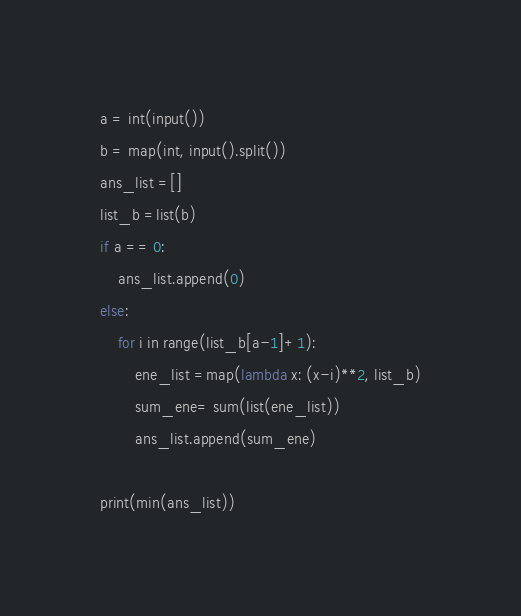Convert code to text. <code><loc_0><loc_0><loc_500><loc_500><_Python_>a = int(input())
b = map(int, input().split())
ans_list =[]
list_b =list(b)
if a == 0:
    ans_list.append(0)
else:
    for i in range(list_b[a-1]+1):
        ene_list =map(lambda x: (x-i)**2, list_b)
        sum_ene= sum(list(ene_list))
        ans_list.append(sum_ene)

print(min(ans_list))</code> 